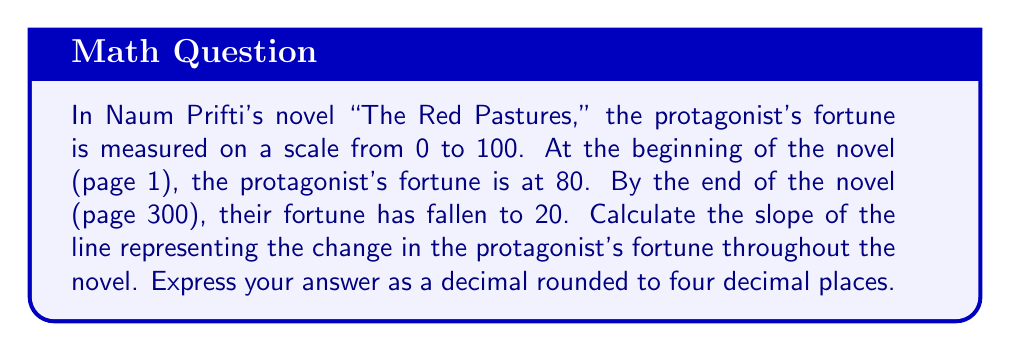Can you solve this math problem? To calculate the slope of the line representing the change in the protagonist's fortune, we'll use the slope formula:

$$ m = \frac{y_2 - y_1}{x_2 - x_1} $$

Where:
- $(x_1, y_1)$ is the initial point (page number, fortune)
- $(x_2, y_2)$ is the final point (page number, fortune)

Given:
- Initial point: $(1, 80)$
- Final point: $(300, 20)$

Let's substitute these values into the slope formula:

$$ m = \frac{20 - 80}{300 - 1} $$

$$ m = \frac{-60}{299} $$

Now, let's perform the division:

$$ m \approx -0.2006688963210702 $$

Rounding to four decimal places:

$$ m \approx -0.2007 $$

This negative slope indicates that the protagonist's fortune decreases as the novel progresses.
Answer: $-0.2007$ 